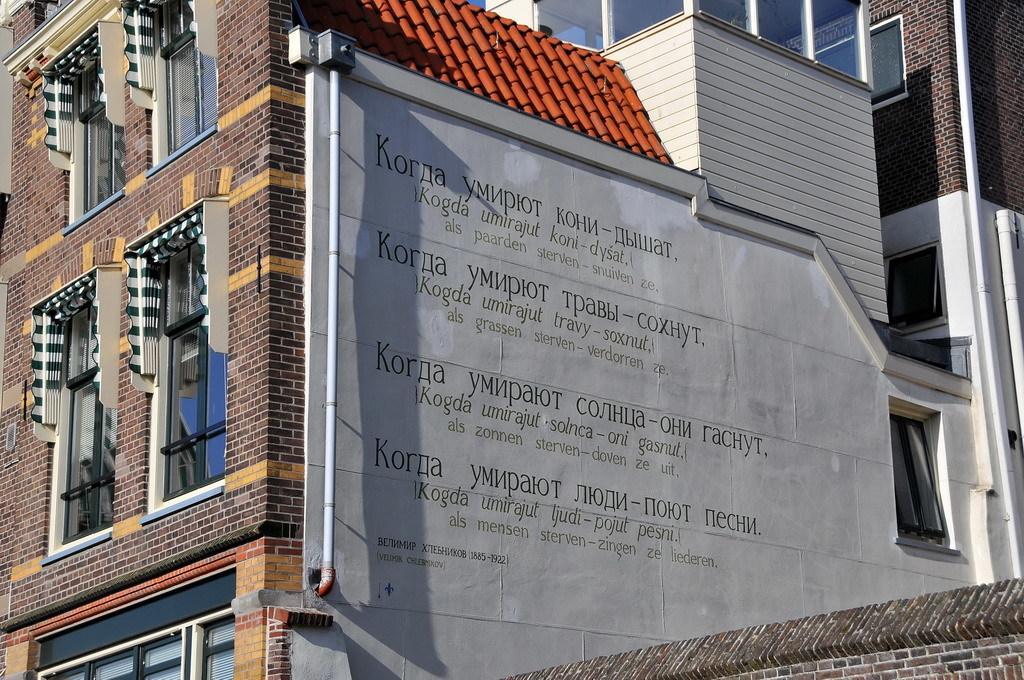Please provide a concise description of this image. As we can see in the image there is a building, windows, pipe and red color rooftop. 